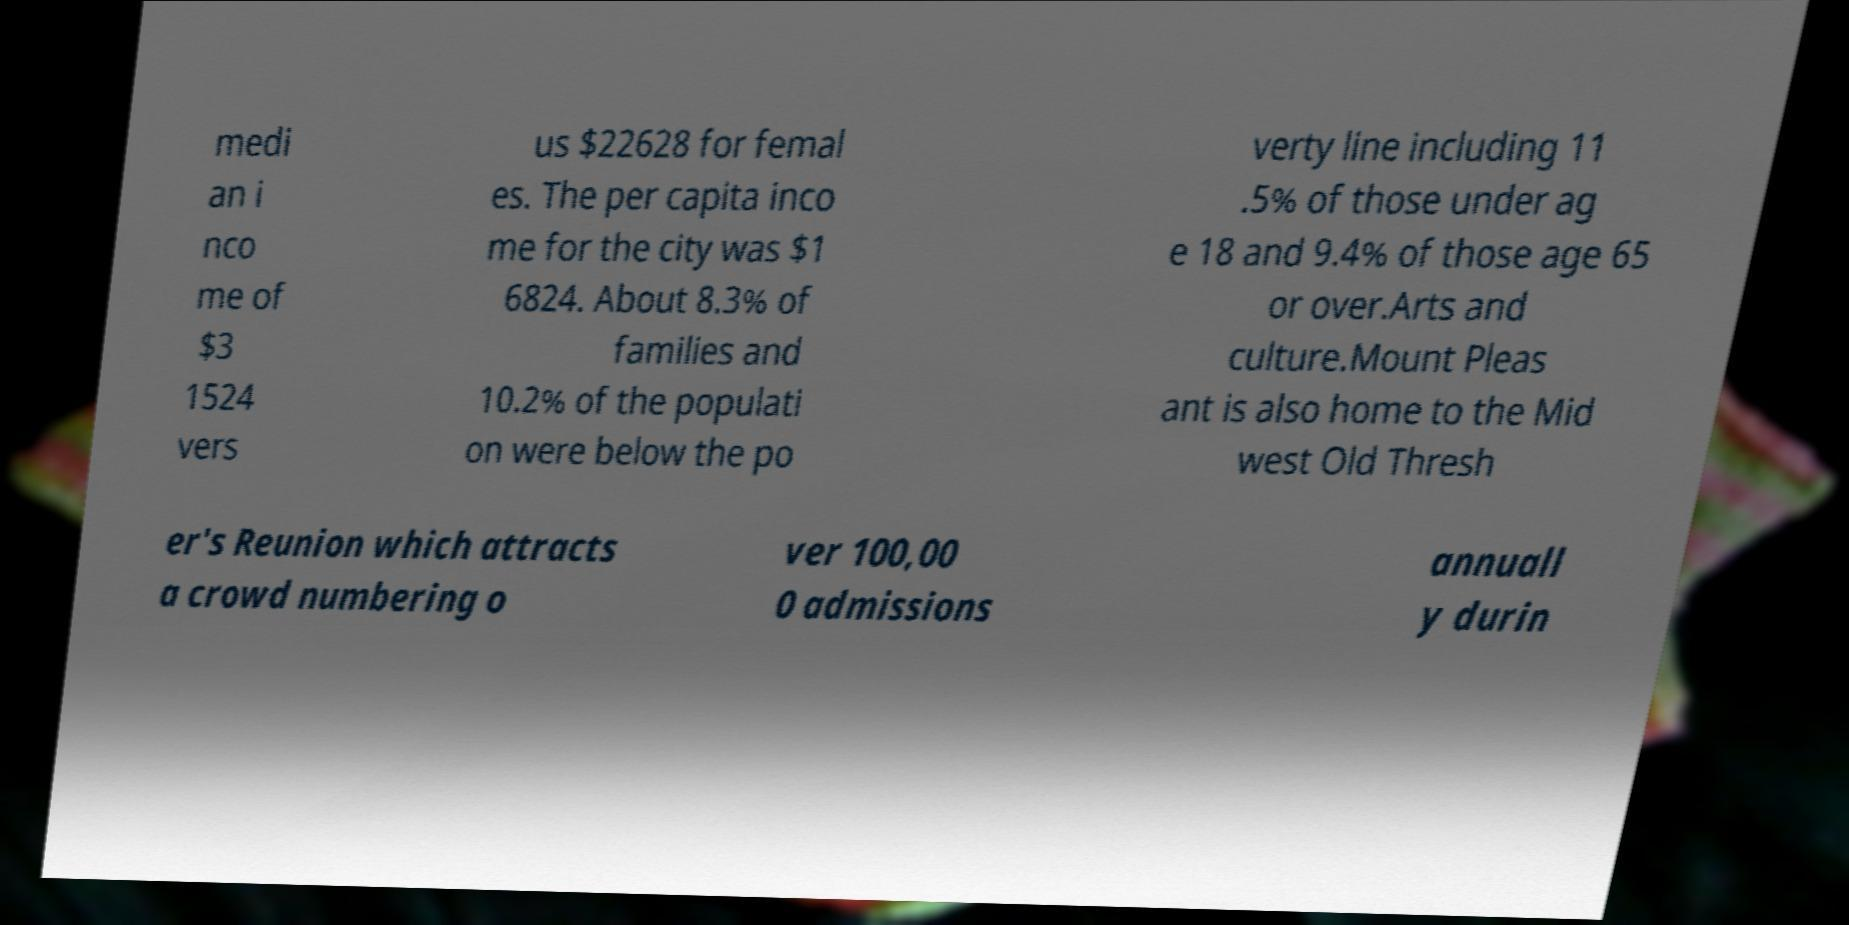Could you assist in decoding the text presented in this image and type it out clearly? medi an i nco me of $3 1524 vers us $22628 for femal es. The per capita inco me for the city was $1 6824. About 8.3% of families and 10.2% of the populati on were below the po verty line including 11 .5% of those under ag e 18 and 9.4% of those age 65 or over.Arts and culture.Mount Pleas ant is also home to the Mid west Old Thresh er's Reunion which attracts a crowd numbering o ver 100,00 0 admissions annuall y durin 